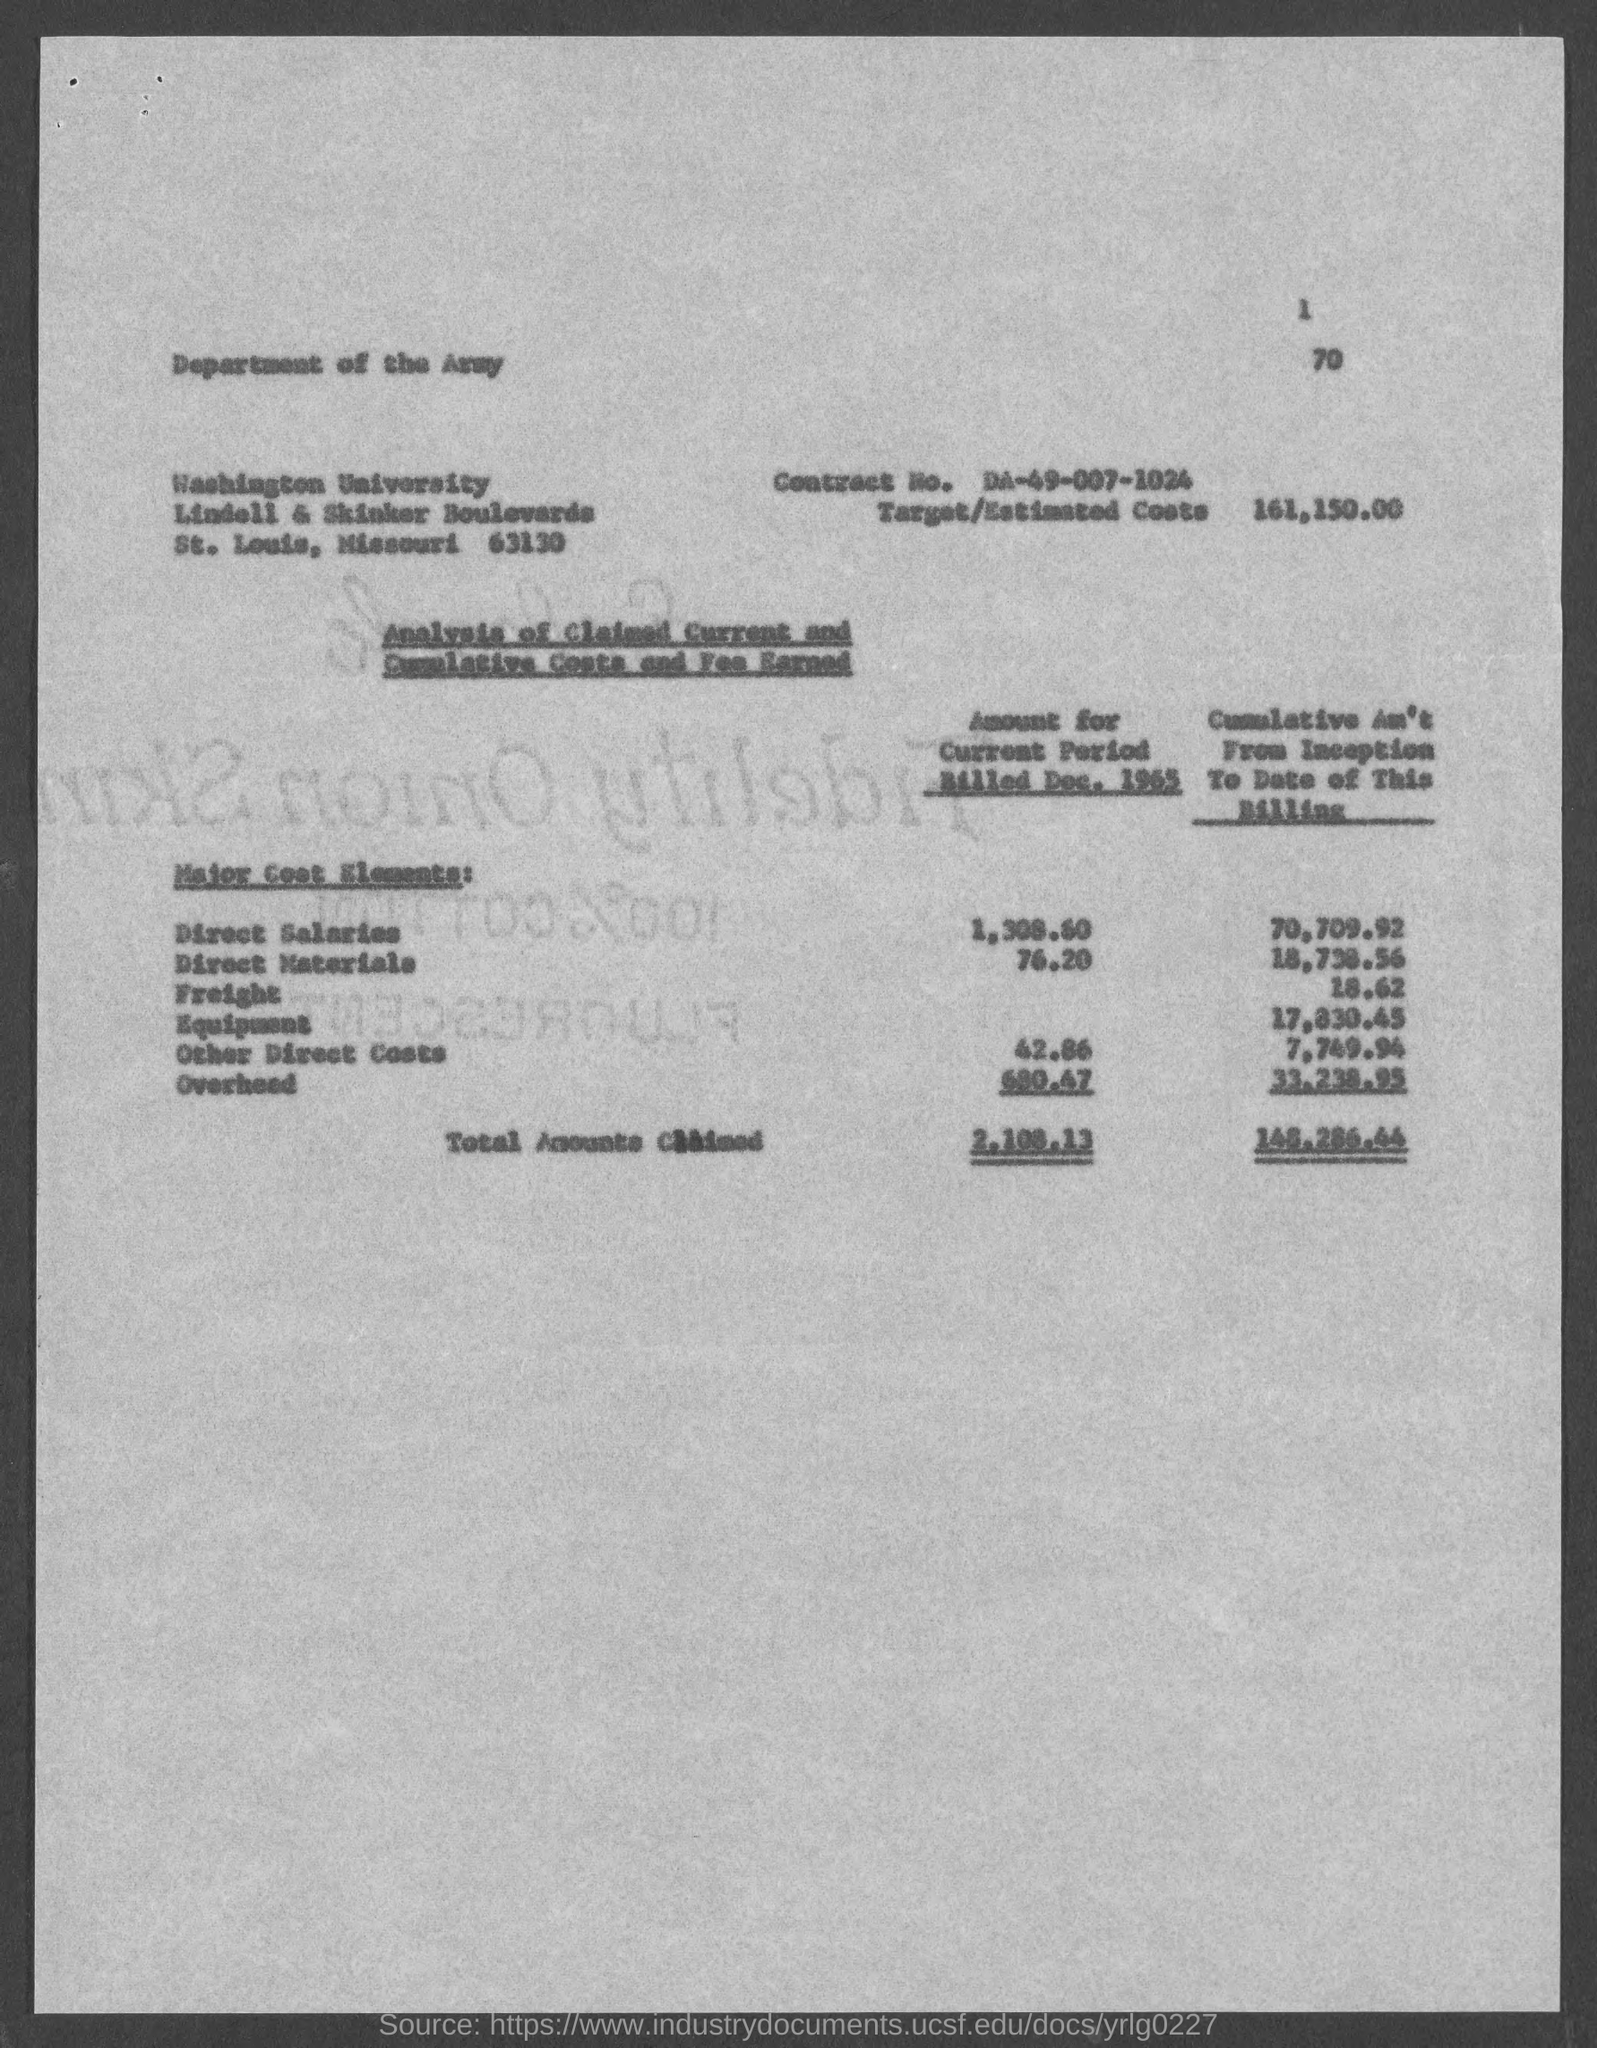Give some essential details in this illustration. The cumulative amount for freight from the beginning of this billing to the current date is 18.62. The cumulative amount for equipment from the inception to the current date is $17,830.45. The total amount claimed for the current period billed in December 1965 was 2,108.13. The target/estimated costs in the document are 161,150.00. The direct materials amount for the current period billed in December 1965 was $76.20. 